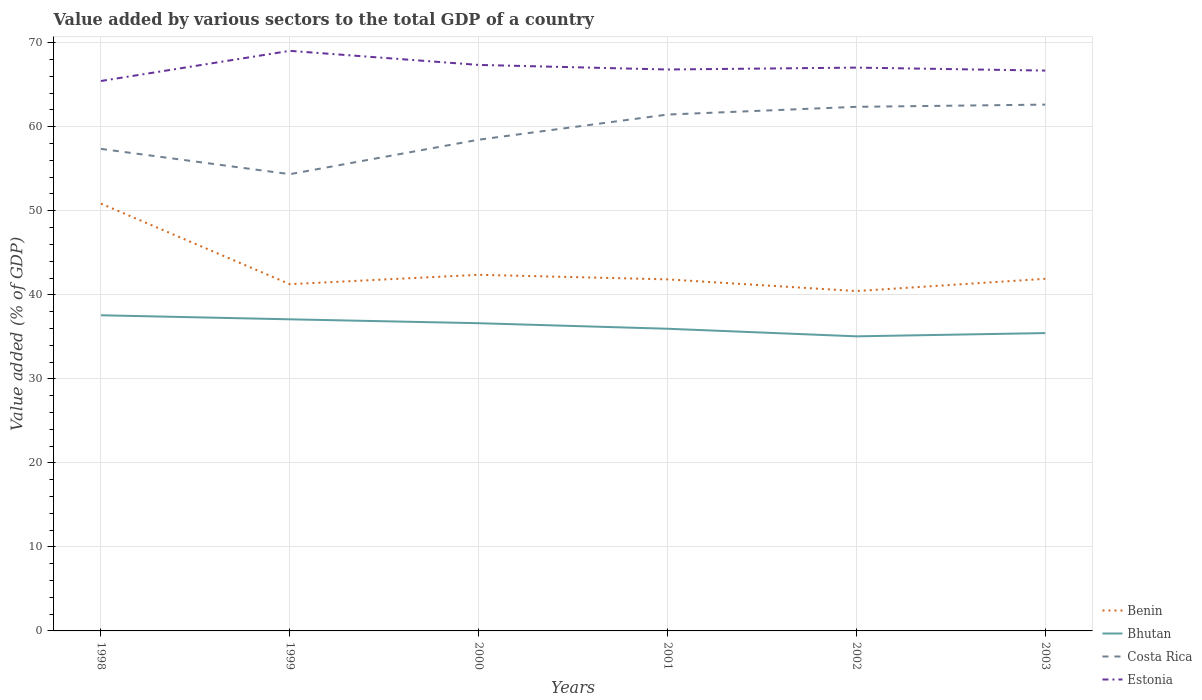Across all years, what is the maximum value added by various sectors to the total GDP in Costa Rica?
Provide a succinct answer. 54.36. In which year was the value added by various sectors to the total GDP in Costa Rica maximum?
Provide a short and direct response. 1999. What is the total value added by various sectors to the total GDP in Estonia in the graph?
Keep it short and to the point. 0.13. What is the difference between the highest and the second highest value added by various sectors to the total GDP in Bhutan?
Provide a short and direct response. 2.51. What is the difference between the highest and the lowest value added by various sectors to the total GDP in Estonia?
Ensure brevity in your answer.  2. Is the value added by various sectors to the total GDP in Costa Rica strictly greater than the value added by various sectors to the total GDP in Bhutan over the years?
Your answer should be very brief. No. Does the graph contain any zero values?
Ensure brevity in your answer.  No. Does the graph contain grids?
Offer a terse response. Yes. How many legend labels are there?
Ensure brevity in your answer.  4. What is the title of the graph?
Your response must be concise. Value added by various sectors to the total GDP of a country. What is the label or title of the Y-axis?
Offer a terse response. Value added (% of GDP). What is the Value added (% of GDP) in Benin in 1998?
Your answer should be compact. 50.86. What is the Value added (% of GDP) in Bhutan in 1998?
Your answer should be compact. 37.57. What is the Value added (% of GDP) of Costa Rica in 1998?
Provide a succinct answer. 57.37. What is the Value added (% of GDP) in Estonia in 1998?
Provide a succinct answer. 65.45. What is the Value added (% of GDP) in Benin in 1999?
Keep it short and to the point. 41.26. What is the Value added (% of GDP) in Bhutan in 1999?
Provide a short and direct response. 37.08. What is the Value added (% of GDP) in Costa Rica in 1999?
Give a very brief answer. 54.36. What is the Value added (% of GDP) of Estonia in 1999?
Offer a very short reply. 69.03. What is the Value added (% of GDP) in Benin in 2000?
Offer a very short reply. 42.38. What is the Value added (% of GDP) of Bhutan in 2000?
Keep it short and to the point. 36.62. What is the Value added (% of GDP) in Costa Rica in 2000?
Provide a succinct answer. 58.46. What is the Value added (% of GDP) of Estonia in 2000?
Provide a short and direct response. 67.36. What is the Value added (% of GDP) in Benin in 2001?
Ensure brevity in your answer.  41.84. What is the Value added (% of GDP) in Bhutan in 2001?
Provide a short and direct response. 35.96. What is the Value added (% of GDP) of Costa Rica in 2001?
Keep it short and to the point. 61.45. What is the Value added (% of GDP) in Estonia in 2001?
Make the answer very short. 66.81. What is the Value added (% of GDP) in Benin in 2002?
Your response must be concise. 40.45. What is the Value added (% of GDP) of Bhutan in 2002?
Offer a terse response. 35.06. What is the Value added (% of GDP) of Costa Rica in 2002?
Give a very brief answer. 62.37. What is the Value added (% of GDP) of Estonia in 2002?
Ensure brevity in your answer.  67.04. What is the Value added (% of GDP) in Benin in 2003?
Make the answer very short. 41.9. What is the Value added (% of GDP) in Bhutan in 2003?
Make the answer very short. 35.45. What is the Value added (% of GDP) in Costa Rica in 2003?
Your answer should be very brief. 62.64. What is the Value added (% of GDP) in Estonia in 2003?
Provide a short and direct response. 66.68. Across all years, what is the maximum Value added (% of GDP) of Benin?
Your answer should be compact. 50.86. Across all years, what is the maximum Value added (% of GDP) of Bhutan?
Offer a very short reply. 37.57. Across all years, what is the maximum Value added (% of GDP) in Costa Rica?
Offer a terse response. 62.64. Across all years, what is the maximum Value added (% of GDP) of Estonia?
Keep it short and to the point. 69.03. Across all years, what is the minimum Value added (% of GDP) in Benin?
Your answer should be very brief. 40.45. Across all years, what is the minimum Value added (% of GDP) in Bhutan?
Give a very brief answer. 35.06. Across all years, what is the minimum Value added (% of GDP) in Costa Rica?
Give a very brief answer. 54.36. Across all years, what is the minimum Value added (% of GDP) of Estonia?
Offer a terse response. 65.45. What is the total Value added (% of GDP) of Benin in the graph?
Provide a succinct answer. 258.69. What is the total Value added (% of GDP) in Bhutan in the graph?
Offer a very short reply. 217.74. What is the total Value added (% of GDP) of Costa Rica in the graph?
Provide a short and direct response. 356.64. What is the total Value added (% of GDP) in Estonia in the graph?
Make the answer very short. 402.37. What is the difference between the Value added (% of GDP) of Benin in 1998 and that in 1999?
Provide a succinct answer. 9.59. What is the difference between the Value added (% of GDP) of Bhutan in 1998 and that in 1999?
Ensure brevity in your answer.  0.48. What is the difference between the Value added (% of GDP) of Costa Rica in 1998 and that in 1999?
Make the answer very short. 3.01. What is the difference between the Value added (% of GDP) in Estonia in 1998 and that in 1999?
Make the answer very short. -3.59. What is the difference between the Value added (% of GDP) of Benin in 1998 and that in 2000?
Keep it short and to the point. 8.47. What is the difference between the Value added (% of GDP) of Bhutan in 1998 and that in 2000?
Provide a short and direct response. 0.95. What is the difference between the Value added (% of GDP) in Costa Rica in 1998 and that in 2000?
Your response must be concise. -1.09. What is the difference between the Value added (% of GDP) of Estonia in 1998 and that in 2000?
Keep it short and to the point. -1.91. What is the difference between the Value added (% of GDP) of Benin in 1998 and that in 2001?
Your answer should be very brief. 9.02. What is the difference between the Value added (% of GDP) of Bhutan in 1998 and that in 2001?
Offer a terse response. 1.61. What is the difference between the Value added (% of GDP) of Costa Rica in 1998 and that in 2001?
Your response must be concise. -4.09. What is the difference between the Value added (% of GDP) of Estonia in 1998 and that in 2001?
Offer a very short reply. -1.37. What is the difference between the Value added (% of GDP) of Benin in 1998 and that in 2002?
Your response must be concise. 10.41. What is the difference between the Value added (% of GDP) in Bhutan in 1998 and that in 2002?
Your answer should be very brief. 2.51. What is the difference between the Value added (% of GDP) in Costa Rica in 1998 and that in 2002?
Offer a very short reply. -5.01. What is the difference between the Value added (% of GDP) of Estonia in 1998 and that in 2002?
Keep it short and to the point. -1.59. What is the difference between the Value added (% of GDP) of Benin in 1998 and that in 2003?
Keep it short and to the point. 8.95. What is the difference between the Value added (% of GDP) in Bhutan in 1998 and that in 2003?
Give a very brief answer. 2.12. What is the difference between the Value added (% of GDP) in Costa Rica in 1998 and that in 2003?
Offer a very short reply. -5.27. What is the difference between the Value added (% of GDP) of Estonia in 1998 and that in 2003?
Your response must be concise. -1.24. What is the difference between the Value added (% of GDP) in Benin in 1999 and that in 2000?
Give a very brief answer. -1.12. What is the difference between the Value added (% of GDP) in Bhutan in 1999 and that in 2000?
Provide a short and direct response. 0.46. What is the difference between the Value added (% of GDP) in Costa Rica in 1999 and that in 2000?
Make the answer very short. -4.1. What is the difference between the Value added (% of GDP) of Estonia in 1999 and that in 2000?
Keep it short and to the point. 1.68. What is the difference between the Value added (% of GDP) of Benin in 1999 and that in 2001?
Ensure brevity in your answer.  -0.57. What is the difference between the Value added (% of GDP) in Bhutan in 1999 and that in 2001?
Give a very brief answer. 1.12. What is the difference between the Value added (% of GDP) in Costa Rica in 1999 and that in 2001?
Your answer should be compact. -7.1. What is the difference between the Value added (% of GDP) in Estonia in 1999 and that in 2001?
Your response must be concise. 2.22. What is the difference between the Value added (% of GDP) of Benin in 1999 and that in 2002?
Make the answer very short. 0.82. What is the difference between the Value added (% of GDP) in Bhutan in 1999 and that in 2002?
Provide a short and direct response. 2.02. What is the difference between the Value added (% of GDP) of Costa Rica in 1999 and that in 2002?
Keep it short and to the point. -8.02. What is the difference between the Value added (% of GDP) in Estonia in 1999 and that in 2002?
Your response must be concise. 2. What is the difference between the Value added (% of GDP) in Benin in 1999 and that in 2003?
Make the answer very short. -0.64. What is the difference between the Value added (% of GDP) of Bhutan in 1999 and that in 2003?
Your answer should be very brief. 1.64. What is the difference between the Value added (% of GDP) of Costa Rica in 1999 and that in 2003?
Ensure brevity in your answer.  -8.28. What is the difference between the Value added (% of GDP) of Estonia in 1999 and that in 2003?
Your response must be concise. 2.35. What is the difference between the Value added (% of GDP) of Benin in 2000 and that in 2001?
Keep it short and to the point. 0.55. What is the difference between the Value added (% of GDP) of Bhutan in 2000 and that in 2001?
Ensure brevity in your answer.  0.66. What is the difference between the Value added (% of GDP) in Costa Rica in 2000 and that in 2001?
Provide a short and direct response. -2.99. What is the difference between the Value added (% of GDP) in Estonia in 2000 and that in 2001?
Provide a succinct answer. 0.54. What is the difference between the Value added (% of GDP) of Benin in 2000 and that in 2002?
Your answer should be very brief. 1.94. What is the difference between the Value added (% of GDP) in Bhutan in 2000 and that in 2002?
Offer a terse response. 1.56. What is the difference between the Value added (% of GDP) in Costa Rica in 2000 and that in 2002?
Offer a terse response. -3.91. What is the difference between the Value added (% of GDP) in Estonia in 2000 and that in 2002?
Provide a short and direct response. 0.32. What is the difference between the Value added (% of GDP) in Benin in 2000 and that in 2003?
Provide a short and direct response. 0.48. What is the difference between the Value added (% of GDP) in Bhutan in 2000 and that in 2003?
Your answer should be very brief. 1.17. What is the difference between the Value added (% of GDP) in Costa Rica in 2000 and that in 2003?
Your answer should be very brief. -4.18. What is the difference between the Value added (% of GDP) of Estonia in 2000 and that in 2003?
Ensure brevity in your answer.  0.67. What is the difference between the Value added (% of GDP) in Benin in 2001 and that in 2002?
Give a very brief answer. 1.39. What is the difference between the Value added (% of GDP) in Bhutan in 2001 and that in 2002?
Your answer should be very brief. 0.9. What is the difference between the Value added (% of GDP) in Costa Rica in 2001 and that in 2002?
Provide a short and direct response. -0.92. What is the difference between the Value added (% of GDP) of Estonia in 2001 and that in 2002?
Your answer should be compact. -0.22. What is the difference between the Value added (% of GDP) in Benin in 2001 and that in 2003?
Offer a very short reply. -0.07. What is the difference between the Value added (% of GDP) of Bhutan in 2001 and that in 2003?
Ensure brevity in your answer.  0.51. What is the difference between the Value added (% of GDP) of Costa Rica in 2001 and that in 2003?
Keep it short and to the point. -1.18. What is the difference between the Value added (% of GDP) of Estonia in 2001 and that in 2003?
Your answer should be very brief. 0.13. What is the difference between the Value added (% of GDP) in Benin in 2002 and that in 2003?
Keep it short and to the point. -1.46. What is the difference between the Value added (% of GDP) of Bhutan in 2002 and that in 2003?
Offer a terse response. -0.39. What is the difference between the Value added (% of GDP) in Costa Rica in 2002 and that in 2003?
Provide a short and direct response. -0.26. What is the difference between the Value added (% of GDP) in Estonia in 2002 and that in 2003?
Ensure brevity in your answer.  0.35. What is the difference between the Value added (% of GDP) of Benin in 1998 and the Value added (% of GDP) of Bhutan in 1999?
Provide a short and direct response. 13.77. What is the difference between the Value added (% of GDP) in Benin in 1998 and the Value added (% of GDP) in Costa Rica in 1999?
Offer a terse response. -3.5. What is the difference between the Value added (% of GDP) of Benin in 1998 and the Value added (% of GDP) of Estonia in 1999?
Your answer should be compact. -18.18. What is the difference between the Value added (% of GDP) in Bhutan in 1998 and the Value added (% of GDP) in Costa Rica in 1999?
Make the answer very short. -16.79. What is the difference between the Value added (% of GDP) of Bhutan in 1998 and the Value added (% of GDP) of Estonia in 1999?
Offer a terse response. -31.47. What is the difference between the Value added (% of GDP) of Costa Rica in 1998 and the Value added (% of GDP) of Estonia in 1999?
Make the answer very short. -11.67. What is the difference between the Value added (% of GDP) of Benin in 1998 and the Value added (% of GDP) of Bhutan in 2000?
Your answer should be compact. 14.24. What is the difference between the Value added (% of GDP) in Benin in 1998 and the Value added (% of GDP) in Costa Rica in 2000?
Provide a short and direct response. -7.6. What is the difference between the Value added (% of GDP) in Benin in 1998 and the Value added (% of GDP) in Estonia in 2000?
Ensure brevity in your answer.  -16.5. What is the difference between the Value added (% of GDP) of Bhutan in 1998 and the Value added (% of GDP) of Costa Rica in 2000?
Offer a terse response. -20.89. What is the difference between the Value added (% of GDP) of Bhutan in 1998 and the Value added (% of GDP) of Estonia in 2000?
Ensure brevity in your answer.  -29.79. What is the difference between the Value added (% of GDP) in Costa Rica in 1998 and the Value added (% of GDP) in Estonia in 2000?
Ensure brevity in your answer.  -9.99. What is the difference between the Value added (% of GDP) of Benin in 1998 and the Value added (% of GDP) of Bhutan in 2001?
Your answer should be compact. 14.9. What is the difference between the Value added (% of GDP) of Benin in 1998 and the Value added (% of GDP) of Costa Rica in 2001?
Provide a short and direct response. -10.59. What is the difference between the Value added (% of GDP) of Benin in 1998 and the Value added (% of GDP) of Estonia in 2001?
Offer a terse response. -15.96. What is the difference between the Value added (% of GDP) of Bhutan in 1998 and the Value added (% of GDP) of Costa Rica in 2001?
Provide a succinct answer. -23.89. What is the difference between the Value added (% of GDP) in Bhutan in 1998 and the Value added (% of GDP) in Estonia in 2001?
Your answer should be compact. -29.25. What is the difference between the Value added (% of GDP) of Costa Rica in 1998 and the Value added (% of GDP) of Estonia in 2001?
Your response must be concise. -9.45. What is the difference between the Value added (% of GDP) in Benin in 1998 and the Value added (% of GDP) in Bhutan in 2002?
Give a very brief answer. 15.8. What is the difference between the Value added (% of GDP) of Benin in 1998 and the Value added (% of GDP) of Costa Rica in 2002?
Your answer should be very brief. -11.51. What is the difference between the Value added (% of GDP) of Benin in 1998 and the Value added (% of GDP) of Estonia in 2002?
Make the answer very short. -16.18. What is the difference between the Value added (% of GDP) in Bhutan in 1998 and the Value added (% of GDP) in Costa Rica in 2002?
Give a very brief answer. -24.81. What is the difference between the Value added (% of GDP) of Bhutan in 1998 and the Value added (% of GDP) of Estonia in 2002?
Provide a short and direct response. -29.47. What is the difference between the Value added (% of GDP) in Costa Rica in 1998 and the Value added (% of GDP) in Estonia in 2002?
Provide a succinct answer. -9.67. What is the difference between the Value added (% of GDP) in Benin in 1998 and the Value added (% of GDP) in Bhutan in 2003?
Your response must be concise. 15.41. What is the difference between the Value added (% of GDP) in Benin in 1998 and the Value added (% of GDP) in Costa Rica in 2003?
Your answer should be very brief. -11.78. What is the difference between the Value added (% of GDP) in Benin in 1998 and the Value added (% of GDP) in Estonia in 2003?
Give a very brief answer. -15.83. What is the difference between the Value added (% of GDP) of Bhutan in 1998 and the Value added (% of GDP) of Costa Rica in 2003?
Ensure brevity in your answer.  -25.07. What is the difference between the Value added (% of GDP) in Bhutan in 1998 and the Value added (% of GDP) in Estonia in 2003?
Ensure brevity in your answer.  -29.12. What is the difference between the Value added (% of GDP) in Costa Rica in 1998 and the Value added (% of GDP) in Estonia in 2003?
Give a very brief answer. -9.32. What is the difference between the Value added (% of GDP) of Benin in 1999 and the Value added (% of GDP) of Bhutan in 2000?
Your response must be concise. 4.64. What is the difference between the Value added (% of GDP) in Benin in 1999 and the Value added (% of GDP) in Costa Rica in 2000?
Give a very brief answer. -17.2. What is the difference between the Value added (% of GDP) in Benin in 1999 and the Value added (% of GDP) in Estonia in 2000?
Offer a very short reply. -26.09. What is the difference between the Value added (% of GDP) of Bhutan in 1999 and the Value added (% of GDP) of Costa Rica in 2000?
Your answer should be very brief. -21.38. What is the difference between the Value added (% of GDP) in Bhutan in 1999 and the Value added (% of GDP) in Estonia in 2000?
Offer a terse response. -30.28. What is the difference between the Value added (% of GDP) in Costa Rica in 1999 and the Value added (% of GDP) in Estonia in 2000?
Offer a very short reply. -13. What is the difference between the Value added (% of GDP) in Benin in 1999 and the Value added (% of GDP) in Bhutan in 2001?
Provide a succinct answer. 5.3. What is the difference between the Value added (% of GDP) in Benin in 1999 and the Value added (% of GDP) in Costa Rica in 2001?
Offer a terse response. -20.19. What is the difference between the Value added (% of GDP) in Benin in 1999 and the Value added (% of GDP) in Estonia in 2001?
Your response must be concise. -25.55. What is the difference between the Value added (% of GDP) of Bhutan in 1999 and the Value added (% of GDP) of Costa Rica in 2001?
Make the answer very short. -24.37. What is the difference between the Value added (% of GDP) of Bhutan in 1999 and the Value added (% of GDP) of Estonia in 2001?
Your answer should be very brief. -29.73. What is the difference between the Value added (% of GDP) in Costa Rica in 1999 and the Value added (% of GDP) in Estonia in 2001?
Make the answer very short. -12.46. What is the difference between the Value added (% of GDP) of Benin in 1999 and the Value added (% of GDP) of Bhutan in 2002?
Offer a very short reply. 6.21. What is the difference between the Value added (% of GDP) of Benin in 1999 and the Value added (% of GDP) of Costa Rica in 2002?
Keep it short and to the point. -21.11. What is the difference between the Value added (% of GDP) of Benin in 1999 and the Value added (% of GDP) of Estonia in 2002?
Offer a very short reply. -25.77. What is the difference between the Value added (% of GDP) in Bhutan in 1999 and the Value added (% of GDP) in Costa Rica in 2002?
Ensure brevity in your answer.  -25.29. What is the difference between the Value added (% of GDP) in Bhutan in 1999 and the Value added (% of GDP) in Estonia in 2002?
Your answer should be very brief. -29.95. What is the difference between the Value added (% of GDP) of Costa Rica in 1999 and the Value added (% of GDP) of Estonia in 2002?
Your response must be concise. -12.68. What is the difference between the Value added (% of GDP) in Benin in 1999 and the Value added (% of GDP) in Bhutan in 2003?
Ensure brevity in your answer.  5.82. What is the difference between the Value added (% of GDP) in Benin in 1999 and the Value added (% of GDP) in Costa Rica in 2003?
Your answer should be very brief. -21.37. What is the difference between the Value added (% of GDP) of Benin in 1999 and the Value added (% of GDP) of Estonia in 2003?
Offer a very short reply. -25.42. What is the difference between the Value added (% of GDP) of Bhutan in 1999 and the Value added (% of GDP) of Costa Rica in 2003?
Offer a terse response. -25.55. What is the difference between the Value added (% of GDP) of Bhutan in 1999 and the Value added (% of GDP) of Estonia in 2003?
Offer a very short reply. -29.6. What is the difference between the Value added (% of GDP) of Costa Rica in 1999 and the Value added (% of GDP) of Estonia in 2003?
Your response must be concise. -12.33. What is the difference between the Value added (% of GDP) in Benin in 2000 and the Value added (% of GDP) in Bhutan in 2001?
Give a very brief answer. 6.42. What is the difference between the Value added (% of GDP) of Benin in 2000 and the Value added (% of GDP) of Costa Rica in 2001?
Provide a succinct answer. -19.07. What is the difference between the Value added (% of GDP) of Benin in 2000 and the Value added (% of GDP) of Estonia in 2001?
Offer a very short reply. -24.43. What is the difference between the Value added (% of GDP) of Bhutan in 2000 and the Value added (% of GDP) of Costa Rica in 2001?
Your answer should be very brief. -24.83. What is the difference between the Value added (% of GDP) in Bhutan in 2000 and the Value added (% of GDP) in Estonia in 2001?
Ensure brevity in your answer.  -30.19. What is the difference between the Value added (% of GDP) of Costa Rica in 2000 and the Value added (% of GDP) of Estonia in 2001?
Give a very brief answer. -8.35. What is the difference between the Value added (% of GDP) of Benin in 2000 and the Value added (% of GDP) of Bhutan in 2002?
Provide a succinct answer. 7.32. What is the difference between the Value added (% of GDP) in Benin in 2000 and the Value added (% of GDP) in Costa Rica in 2002?
Your answer should be very brief. -19.99. What is the difference between the Value added (% of GDP) of Benin in 2000 and the Value added (% of GDP) of Estonia in 2002?
Your answer should be compact. -24.66. What is the difference between the Value added (% of GDP) of Bhutan in 2000 and the Value added (% of GDP) of Costa Rica in 2002?
Offer a terse response. -25.75. What is the difference between the Value added (% of GDP) of Bhutan in 2000 and the Value added (% of GDP) of Estonia in 2002?
Provide a succinct answer. -30.42. What is the difference between the Value added (% of GDP) in Costa Rica in 2000 and the Value added (% of GDP) in Estonia in 2002?
Your answer should be compact. -8.58. What is the difference between the Value added (% of GDP) in Benin in 2000 and the Value added (% of GDP) in Bhutan in 2003?
Keep it short and to the point. 6.94. What is the difference between the Value added (% of GDP) of Benin in 2000 and the Value added (% of GDP) of Costa Rica in 2003?
Provide a succinct answer. -20.25. What is the difference between the Value added (% of GDP) of Benin in 2000 and the Value added (% of GDP) of Estonia in 2003?
Your answer should be very brief. -24.3. What is the difference between the Value added (% of GDP) of Bhutan in 2000 and the Value added (% of GDP) of Costa Rica in 2003?
Your answer should be very brief. -26.02. What is the difference between the Value added (% of GDP) of Bhutan in 2000 and the Value added (% of GDP) of Estonia in 2003?
Your response must be concise. -30.06. What is the difference between the Value added (% of GDP) of Costa Rica in 2000 and the Value added (% of GDP) of Estonia in 2003?
Ensure brevity in your answer.  -8.22. What is the difference between the Value added (% of GDP) of Benin in 2001 and the Value added (% of GDP) of Bhutan in 2002?
Keep it short and to the point. 6.78. What is the difference between the Value added (% of GDP) of Benin in 2001 and the Value added (% of GDP) of Costa Rica in 2002?
Your answer should be very brief. -20.54. What is the difference between the Value added (% of GDP) in Benin in 2001 and the Value added (% of GDP) in Estonia in 2002?
Your response must be concise. -25.2. What is the difference between the Value added (% of GDP) of Bhutan in 2001 and the Value added (% of GDP) of Costa Rica in 2002?
Give a very brief answer. -26.41. What is the difference between the Value added (% of GDP) in Bhutan in 2001 and the Value added (% of GDP) in Estonia in 2002?
Keep it short and to the point. -31.08. What is the difference between the Value added (% of GDP) in Costa Rica in 2001 and the Value added (% of GDP) in Estonia in 2002?
Your response must be concise. -5.59. What is the difference between the Value added (% of GDP) in Benin in 2001 and the Value added (% of GDP) in Bhutan in 2003?
Provide a succinct answer. 6.39. What is the difference between the Value added (% of GDP) in Benin in 2001 and the Value added (% of GDP) in Costa Rica in 2003?
Keep it short and to the point. -20.8. What is the difference between the Value added (% of GDP) in Benin in 2001 and the Value added (% of GDP) in Estonia in 2003?
Provide a succinct answer. -24.85. What is the difference between the Value added (% of GDP) in Bhutan in 2001 and the Value added (% of GDP) in Costa Rica in 2003?
Keep it short and to the point. -26.67. What is the difference between the Value added (% of GDP) in Bhutan in 2001 and the Value added (% of GDP) in Estonia in 2003?
Your answer should be compact. -30.72. What is the difference between the Value added (% of GDP) of Costa Rica in 2001 and the Value added (% of GDP) of Estonia in 2003?
Offer a terse response. -5.23. What is the difference between the Value added (% of GDP) of Benin in 2002 and the Value added (% of GDP) of Bhutan in 2003?
Provide a succinct answer. 5. What is the difference between the Value added (% of GDP) of Benin in 2002 and the Value added (% of GDP) of Costa Rica in 2003?
Your response must be concise. -22.19. What is the difference between the Value added (% of GDP) in Benin in 2002 and the Value added (% of GDP) in Estonia in 2003?
Keep it short and to the point. -26.24. What is the difference between the Value added (% of GDP) of Bhutan in 2002 and the Value added (% of GDP) of Costa Rica in 2003?
Offer a very short reply. -27.58. What is the difference between the Value added (% of GDP) in Bhutan in 2002 and the Value added (% of GDP) in Estonia in 2003?
Offer a terse response. -31.63. What is the difference between the Value added (% of GDP) in Costa Rica in 2002 and the Value added (% of GDP) in Estonia in 2003?
Your answer should be very brief. -4.31. What is the average Value added (% of GDP) in Benin per year?
Provide a short and direct response. 43.12. What is the average Value added (% of GDP) in Bhutan per year?
Offer a very short reply. 36.29. What is the average Value added (% of GDP) in Costa Rica per year?
Give a very brief answer. 59.44. What is the average Value added (% of GDP) of Estonia per year?
Provide a short and direct response. 67.06. In the year 1998, what is the difference between the Value added (% of GDP) of Benin and Value added (% of GDP) of Bhutan?
Provide a short and direct response. 13.29. In the year 1998, what is the difference between the Value added (% of GDP) in Benin and Value added (% of GDP) in Costa Rica?
Provide a succinct answer. -6.51. In the year 1998, what is the difference between the Value added (% of GDP) in Benin and Value added (% of GDP) in Estonia?
Make the answer very short. -14.59. In the year 1998, what is the difference between the Value added (% of GDP) of Bhutan and Value added (% of GDP) of Costa Rica?
Provide a succinct answer. -19.8. In the year 1998, what is the difference between the Value added (% of GDP) of Bhutan and Value added (% of GDP) of Estonia?
Provide a short and direct response. -27.88. In the year 1998, what is the difference between the Value added (% of GDP) in Costa Rica and Value added (% of GDP) in Estonia?
Keep it short and to the point. -8.08. In the year 1999, what is the difference between the Value added (% of GDP) of Benin and Value added (% of GDP) of Bhutan?
Offer a very short reply. 4.18. In the year 1999, what is the difference between the Value added (% of GDP) of Benin and Value added (% of GDP) of Costa Rica?
Provide a succinct answer. -13.09. In the year 1999, what is the difference between the Value added (% of GDP) in Benin and Value added (% of GDP) in Estonia?
Offer a very short reply. -27.77. In the year 1999, what is the difference between the Value added (% of GDP) in Bhutan and Value added (% of GDP) in Costa Rica?
Your answer should be compact. -17.27. In the year 1999, what is the difference between the Value added (% of GDP) in Bhutan and Value added (% of GDP) in Estonia?
Ensure brevity in your answer.  -31.95. In the year 1999, what is the difference between the Value added (% of GDP) of Costa Rica and Value added (% of GDP) of Estonia?
Provide a short and direct response. -14.68. In the year 2000, what is the difference between the Value added (% of GDP) in Benin and Value added (% of GDP) in Bhutan?
Ensure brevity in your answer.  5.76. In the year 2000, what is the difference between the Value added (% of GDP) in Benin and Value added (% of GDP) in Costa Rica?
Offer a very short reply. -16.08. In the year 2000, what is the difference between the Value added (% of GDP) in Benin and Value added (% of GDP) in Estonia?
Provide a succinct answer. -24.98. In the year 2000, what is the difference between the Value added (% of GDP) in Bhutan and Value added (% of GDP) in Costa Rica?
Ensure brevity in your answer.  -21.84. In the year 2000, what is the difference between the Value added (% of GDP) of Bhutan and Value added (% of GDP) of Estonia?
Provide a short and direct response. -30.74. In the year 2000, what is the difference between the Value added (% of GDP) of Costa Rica and Value added (% of GDP) of Estonia?
Your answer should be very brief. -8.9. In the year 2001, what is the difference between the Value added (% of GDP) of Benin and Value added (% of GDP) of Bhutan?
Offer a very short reply. 5.88. In the year 2001, what is the difference between the Value added (% of GDP) in Benin and Value added (% of GDP) in Costa Rica?
Ensure brevity in your answer.  -19.61. In the year 2001, what is the difference between the Value added (% of GDP) of Benin and Value added (% of GDP) of Estonia?
Make the answer very short. -24.98. In the year 2001, what is the difference between the Value added (% of GDP) of Bhutan and Value added (% of GDP) of Costa Rica?
Provide a short and direct response. -25.49. In the year 2001, what is the difference between the Value added (% of GDP) of Bhutan and Value added (% of GDP) of Estonia?
Your answer should be compact. -30.85. In the year 2001, what is the difference between the Value added (% of GDP) of Costa Rica and Value added (% of GDP) of Estonia?
Make the answer very short. -5.36. In the year 2002, what is the difference between the Value added (% of GDP) of Benin and Value added (% of GDP) of Bhutan?
Ensure brevity in your answer.  5.39. In the year 2002, what is the difference between the Value added (% of GDP) in Benin and Value added (% of GDP) in Costa Rica?
Your answer should be compact. -21.93. In the year 2002, what is the difference between the Value added (% of GDP) of Benin and Value added (% of GDP) of Estonia?
Ensure brevity in your answer.  -26.59. In the year 2002, what is the difference between the Value added (% of GDP) of Bhutan and Value added (% of GDP) of Costa Rica?
Make the answer very short. -27.31. In the year 2002, what is the difference between the Value added (% of GDP) in Bhutan and Value added (% of GDP) in Estonia?
Give a very brief answer. -31.98. In the year 2002, what is the difference between the Value added (% of GDP) in Costa Rica and Value added (% of GDP) in Estonia?
Give a very brief answer. -4.67. In the year 2003, what is the difference between the Value added (% of GDP) of Benin and Value added (% of GDP) of Bhutan?
Provide a succinct answer. 6.46. In the year 2003, what is the difference between the Value added (% of GDP) of Benin and Value added (% of GDP) of Costa Rica?
Your answer should be compact. -20.73. In the year 2003, what is the difference between the Value added (% of GDP) in Benin and Value added (% of GDP) in Estonia?
Give a very brief answer. -24.78. In the year 2003, what is the difference between the Value added (% of GDP) in Bhutan and Value added (% of GDP) in Costa Rica?
Provide a short and direct response. -27.19. In the year 2003, what is the difference between the Value added (% of GDP) of Bhutan and Value added (% of GDP) of Estonia?
Your answer should be very brief. -31.24. In the year 2003, what is the difference between the Value added (% of GDP) in Costa Rica and Value added (% of GDP) in Estonia?
Your answer should be compact. -4.05. What is the ratio of the Value added (% of GDP) of Benin in 1998 to that in 1999?
Make the answer very short. 1.23. What is the ratio of the Value added (% of GDP) of Bhutan in 1998 to that in 1999?
Give a very brief answer. 1.01. What is the ratio of the Value added (% of GDP) in Costa Rica in 1998 to that in 1999?
Ensure brevity in your answer.  1.06. What is the ratio of the Value added (% of GDP) of Estonia in 1998 to that in 1999?
Provide a succinct answer. 0.95. What is the ratio of the Value added (% of GDP) in Benin in 1998 to that in 2000?
Keep it short and to the point. 1.2. What is the ratio of the Value added (% of GDP) in Bhutan in 1998 to that in 2000?
Make the answer very short. 1.03. What is the ratio of the Value added (% of GDP) in Costa Rica in 1998 to that in 2000?
Ensure brevity in your answer.  0.98. What is the ratio of the Value added (% of GDP) in Estonia in 1998 to that in 2000?
Offer a terse response. 0.97. What is the ratio of the Value added (% of GDP) of Benin in 1998 to that in 2001?
Give a very brief answer. 1.22. What is the ratio of the Value added (% of GDP) of Bhutan in 1998 to that in 2001?
Offer a very short reply. 1.04. What is the ratio of the Value added (% of GDP) in Costa Rica in 1998 to that in 2001?
Ensure brevity in your answer.  0.93. What is the ratio of the Value added (% of GDP) of Estonia in 1998 to that in 2001?
Make the answer very short. 0.98. What is the ratio of the Value added (% of GDP) in Benin in 1998 to that in 2002?
Make the answer very short. 1.26. What is the ratio of the Value added (% of GDP) in Bhutan in 1998 to that in 2002?
Keep it short and to the point. 1.07. What is the ratio of the Value added (% of GDP) in Costa Rica in 1998 to that in 2002?
Keep it short and to the point. 0.92. What is the ratio of the Value added (% of GDP) in Estonia in 1998 to that in 2002?
Offer a very short reply. 0.98. What is the ratio of the Value added (% of GDP) in Benin in 1998 to that in 2003?
Your answer should be compact. 1.21. What is the ratio of the Value added (% of GDP) in Bhutan in 1998 to that in 2003?
Offer a terse response. 1.06. What is the ratio of the Value added (% of GDP) of Costa Rica in 1998 to that in 2003?
Give a very brief answer. 0.92. What is the ratio of the Value added (% of GDP) in Estonia in 1998 to that in 2003?
Provide a succinct answer. 0.98. What is the ratio of the Value added (% of GDP) of Benin in 1999 to that in 2000?
Offer a terse response. 0.97. What is the ratio of the Value added (% of GDP) of Bhutan in 1999 to that in 2000?
Make the answer very short. 1.01. What is the ratio of the Value added (% of GDP) in Costa Rica in 1999 to that in 2000?
Give a very brief answer. 0.93. What is the ratio of the Value added (% of GDP) in Estonia in 1999 to that in 2000?
Your answer should be compact. 1.02. What is the ratio of the Value added (% of GDP) in Benin in 1999 to that in 2001?
Provide a short and direct response. 0.99. What is the ratio of the Value added (% of GDP) of Bhutan in 1999 to that in 2001?
Offer a terse response. 1.03. What is the ratio of the Value added (% of GDP) in Costa Rica in 1999 to that in 2001?
Keep it short and to the point. 0.88. What is the ratio of the Value added (% of GDP) in Estonia in 1999 to that in 2001?
Your response must be concise. 1.03. What is the ratio of the Value added (% of GDP) in Benin in 1999 to that in 2002?
Provide a short and direct response. 1.02. What is the ratio of the Value added (% of GDP) in Bhutan in 1999 to that in 2002?
Give a very brief answer. 1.06. What is the ratio of the Value added (% of GDP) of Costa Rica in 1999 to that in 2002?
Your answer should be compact. 0.87. What is the ratio of the Value added (% of GDP) in Estonia in 1999 to that in 2002?
Provide a succinct answer. 1.03. What is the ratio of the Value added (% of GDP) in Benin in 1999 to that in 2003?
Make the answer very short. 0.98. What is the ratio of the Value added (% of GDP) in Bhutan in 1999 to that in 2003?
Your answer should be compact. 1.05. What is the ratio of the Value added (% of GDP) of Costa Rica in 1999 to that in 2003?
Keep it short and to the point. 0.87. What is the ratio of the Value added (% of GDP) in Estonia in 1999 to that in 2003?
Your answer should be very brief. 1.04. What is the ratio of the Value added (% of GDP) in Benin in 2000 to that in 2001?
Provide a short and direct response. 1.01. What is the ratio of the Value added (% of GDP) of Bhutan in 2000 to that in 2001?
Offer a very short reply. 1.02. What is the ratio of the Value added (% of GDP) of Costa Rica in 2000 to that in 2001?
Make the answer very short. 0.95. What is the ratio of the Value added (% of GDP) in Estonia in 2000 to that in 2001?
Keep it short and to the point. 1.01. What is the ratio of the Value added (% of GDP) in Benin in 2000 to that in 2002?
Keep it short and to the point. 1.05. What is the ratio of the Value added (% of GDP) in Bhutan in 2000 to that in 2002?
Provide a short and direct response. 1.04. What is the ratio of the Value added (% of GDP) in Costa Rica in 2000 to that in 2002?
Offer a terse response. 0.94. What is the ratio of the Value added (% of GDP) in Benin in 2000 to that in 2003?
Give a very brief answer. 1.01. What is the ratio of the Value added (% of GDP) of Bhutan in 2000 to that in 2003?
Provide a succinct answer. 1.03. What is the ratio of the Value added (% of GDP) in Benin in 2001 to that in 2002?
Make the answer very short. 1.03. What is the ratio of the Value added (% of GDP) of Bhutan in 2001 to that in 2002?
Your answer should be very brief. 1.03. What is the ratio of the Value added (% of GDP) in Costa Rica in 2001 to that in 2002?
Give a very brief answer. 0.99. What is the ratio of the Value added (% of GDP) of Benin in 2001 to that in 2003?
Ensure brevity in your answer.  1. What is the ratio of the Value added (% of GDP) of Bhutan in 2001 to that in 2003?
Offer a terse response. 1.01. What is the ratio of the Value added (% of GDP) in Costa Rica in 2001 to that in 2003?
Offer a terse response. 0.98. What is the ratio of the Value added (% of GDP) of Benin in 2002 to that in 2003?
Keep it short and to the point. 0.97. What is the ratio of the Value added (% of GDP) of Bhutan in 2002 to that in 2003?
Give a very brief answer. 0.99. What is the ratio of the Value added (% of GDP) in Costa Rica in 2002 to that in 2003?
Make the answer very short. 1. What is the difference between the highest and the second highest Value added (% of GDP) in Benin?
Offer a terse response. 8.47. What is the difference between the highest and the second highest Value added (% of GDP) in Bhutan?
Make the answer very short. 0.48. What is the difference between the highest and the second highest Value added (% of GDP) of Costa Rica?
Keep it short and to the point. 0.26. What is the difference between the highest and the second highest Value added (% of GDP) of Estonia?
Offer a very short reply. 1.68. What is the difference between the highest and the lowest Value added (% of GDP) of Benin?
Offer a terse response. 10.41. What is the difference between the highest and the lowest Value added (% of GDP) of Bhutan?
Provide a short and direct response. 2.51. What is the difference between the highest and the lowest Value added (% of GDP) in Costa Rica?
Your answer should be compact. 8.28. What is the difference between the highest and the lowest Value added (% of GDP) of Estonia?
Provide a short and direct response. 3.59. 